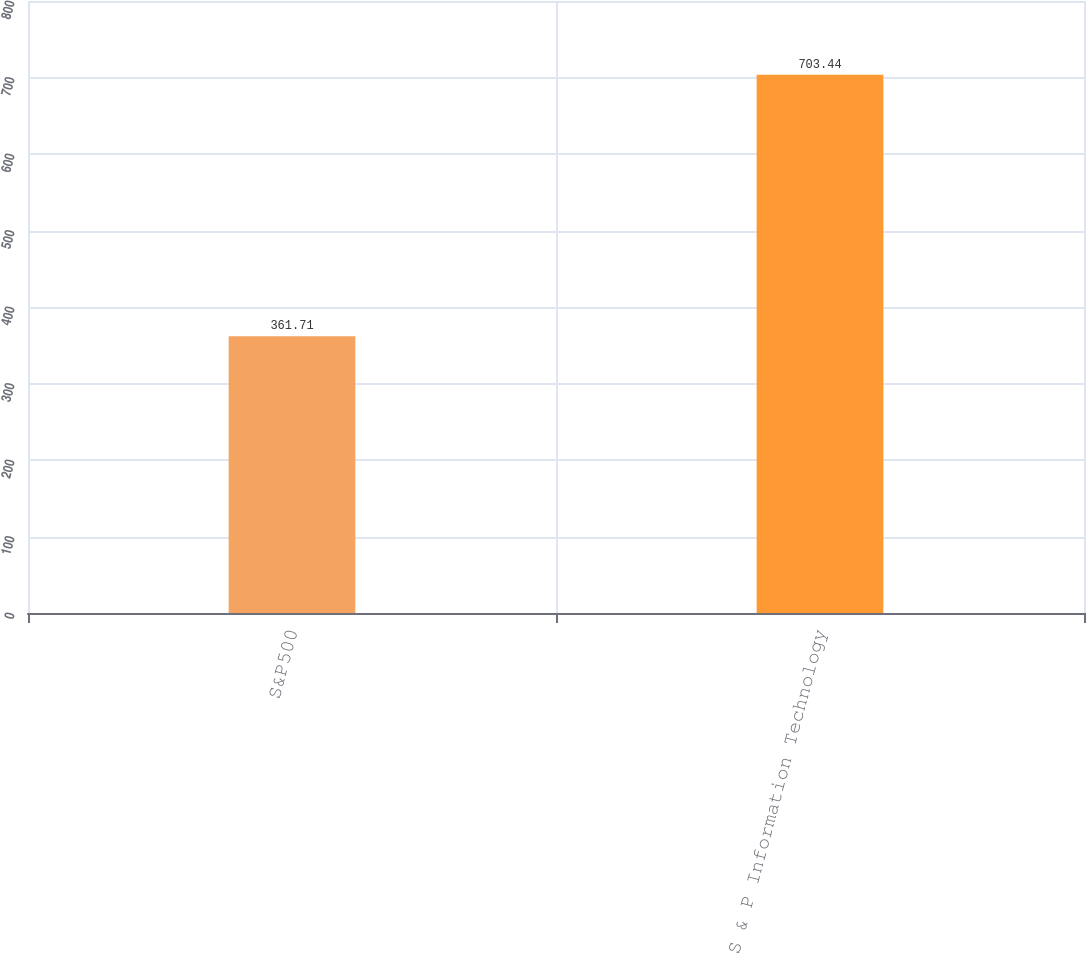Convert chart to OTSL. <chart><loc_0><loc_0><loc_500><loc_500><bar_chart><fcel>S&P500<fcel>S & P Information Technology<nl><fcel>361.71<fcel>703.44<nl></chart> 